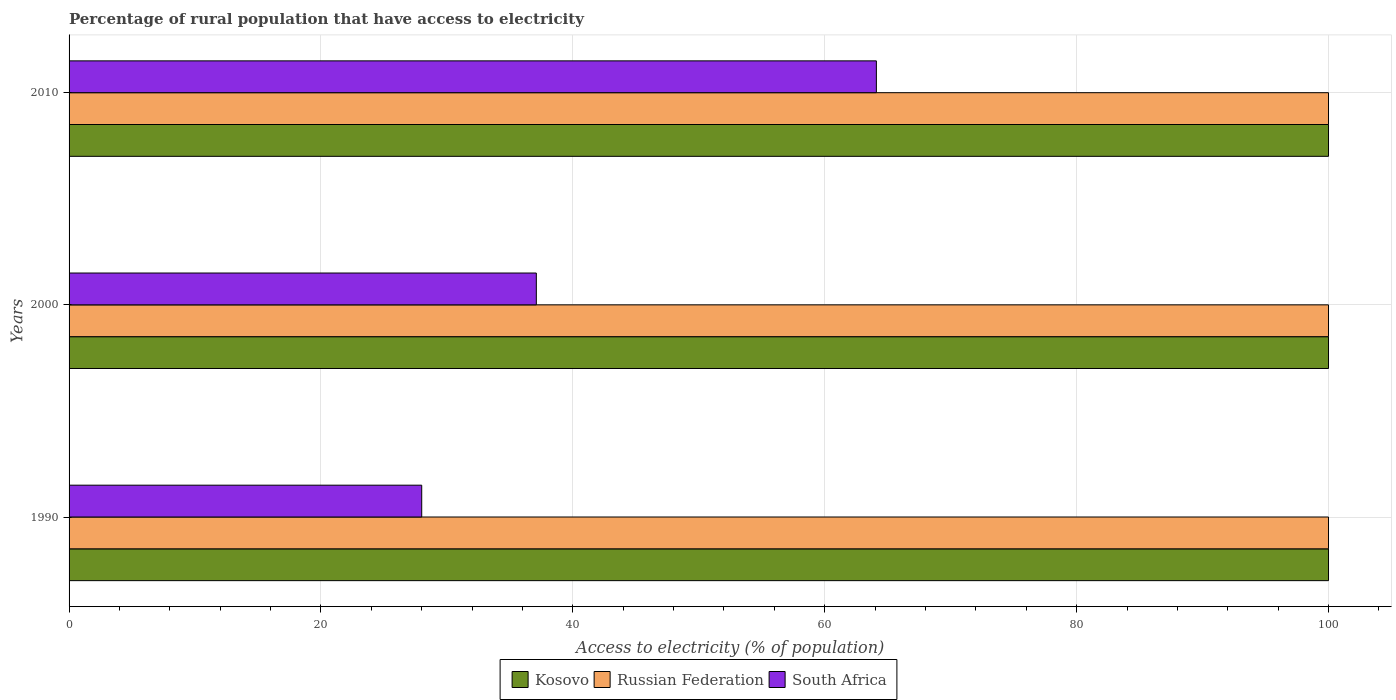How many different coloured bars are there?
Keep it short and to the point. 3. How many groups of bars are there?
Keep it short and to the point. 3. Are the number of bars per tick equal to the number of legend labels?
Offer a terse response. Yes. Are the number of bars on each tick of the Y-axis equal?
Give a very brief answer. Yes. How many bars are there on the 1st tick from the bottom?
Offer a terse response. 3. What is the label of the 3rd group of bars from the top?
Provide a succinct answer. 1990. In how many cases, is the number of bars for a given year not equal to the number of legend labels?
Your answer should be compact. 0. What is the percentage of rural population that have access to electricity in Russian Federation in 2000?
Offer a terse response. 100. Across all years, what is the maximum percentage of rural population that have access to electricity in Kosovo?
Your answer should be very brief. 100. Across all years, what is the minimum percentage of rural population that have access to electricity in Russian Federation?
Your response must be concise. 100. In which year was the percentage of rural population that have access to electricity in Russian Federation maximum?
Your response must be concise. 1990. What is the total percentage of rural population that have access to electricity in South Africa in the graph?
Ensure brevity in your answer.  129.2. What is the difference between the percentage of rural population that have access to electricity in Russian Federation in 1990 and that in 2010?
Offer a very short reply. 0. In the year 2000, what is the difference between the percentage of rural population that have access to electricity in South Africa and percentage of rural population that have access to electricity in Kosovo?
Offer a terse response. -62.9. In how many years, is the percentage of rural population that have access to electricity in South Africa greater than 100 %?
Provide a short and direct response. 0. Is the percentage of rural population that have access to electricity in South Africa in 1990 less than that in 2000?
Your answer should be very brief. Yes. Is the difference between the percentage of rural population that have access to electricity in South Africa in 1990 and 2010 greater than the difference between the percentage of rural population that have access to electricity in Kosovo in 1990 and 2010?
Give a very brief answer. No. What is the difference between the highest and the lowest percentage of rural population that have access to electricity in South Africa?
Keep it short and to the point. 36.1. In how many years, is the percentage of rural population that have access to electricity in Russian Federation greater than the average percentage of rural population that have access to electricity in Russian Federation taken over all years?
Give a very brief answer. 0. Is the sum of the percentage of rural population that have access to electricity in Kosovo in 1990 and 2010 greater than the maximum percentage of rural population that have access to electricity in Russian Federation across all years?
Offer a terse response. Yes. What does the 1st bar from the top in 2000 represents?
Provide a short and direct response. South Africa. What does the 2nd bar from the bottom in 2010 represents?
Offer a very short reply. Russian Federation. Are all the bars in the graph horizontal?
Keep it short and to the point. Yes. What is the difference between two consecutive major ticks on the X-axis?
Make the answer very short. 20. What is the title of the graph?
Offer a very short reply. Percentage of rural population that have access to electricity. What is the label or title of the X-axis?
Give a very brief answer. Access to electricity (% of population). What is the label or title of the Y-axis?
Your response must be concise. Years. What is the Access to electricity (% of population) of Kosovo in 1990?
Offer a very short reply. 100. What is the Access to electricity (% of population) of Kosovo in 2000?
Give a very brief answer. 100. What is the Access to electricity (% of population) of Russian Federation in 2000?
Your response must be concise. 100. What is the Access to electricity (% of population) in South Africa in 2000?
Your answer should be compact. 37.1. What is the Access to electricity (% of population) of South Africa in 2010?
Provide a succinct answer. 64.1. Across all years, what is the maximum Access to electricity (% of population) of South Africa?
Keep it short and to the point. 64.1. Across all years, what is the minimum Access to electricity (% of population) in Russian Federation?
Your answer should be very brief. 100. Across all years, what is the minimum Access to electricity (% of population) in South Africa?
Provide a short and direct response. 28. What is the total Access to electricity (% of population) in Kosovo in the graph?
Your answer should be very brief. 300. What is the total Access to electricity (% of population) in Russian Federation in the graph?
Provide a succinct answer. 300. What is the total Access to electricity (% of population) in South Africa in the graph?
Make the answer very short. 129.2. What is the difference between the Access to electricity (% of population) in South Africa in 1990 and that in 2000?
Your answer should be very brief. -9.1. What is the difference between the Access to electricity (% of population) of Russian Federation in 1990 and that in 2010?
Provide a short and direct response. 0. What is the difference between the Access to electricity (% of population) in South Africa in 1990 and that in 2010?
Make the answer very short. -36.1. What is the difference between the Access to electricity (% of population) in Kosovo in 2000 and that in 2010?
Make the answer very short. 0. What is the difference between the Access to electricity (% of population) in Russian Federation in 2000 and that in 2010?
Keep it short and to the point. 0. What is the difference between the Access to electricity (% of population) of South Africa in 2000 and that in 2010?
Make the answer very short. -27. What is the difference between the Access to electricity (% of population) in Kosovo in 1990 and the Access to electricity (% of population) in South Africa in 2000?
Offer a very short reply. 62.9. What is the difference between the Access to electricity (% of population) of Russian Federation in 1990 and the Access to electricity (% of population) of South Africa in 2000?
Offer a terse response. 62.9. What is the difference between the Access to electricity (% of population) in Kosovo in 1990 and the Access to electricity (% of population) in Russian Federation in 2010?
Offer a very short reply. 0. What is the difference between the Access to electricity (% of population) in Kosovo in 1990 and the Access to electricity (% of population) in South Africa in 2010?
Give a very brief answer. 35.9. What is the difference between the Access to electricity (% of population) of Russian Federation in 1990 and the Access to electricity (% of population) of South Africa in 2010?
Ensure brevity in your answer.  35.9. What is the difference between the Access to electricity (% of population) of Kosovo in 2000 and the Access to electricity (% of population) of Russian Federation in 2010?
Offer a very short reply. 0. What is the difference between the Access to electricity (% of population) of Kosovo in 2000 and the Access to electricity (% of population) of South Africa in 2010?
Your answer should be very brief. 35.9. What is the difference between the Access to electricity (% of population) of Russian Federation in 2000 and the Access to electricity (% of population) of South Africa in 2010?
Make the answer very short. 35.9. What is the average Access to electricity (% of population) of Russian Federation per year?
Offer a terse response. 100. What is the average Access to electricity (% of population) of South Africa per year?
Provide a succinct answer. 43.07. In the year 1990, what is the difference between the Access to electricity (% of population) of Kosovo and Access to electricity (% of population) of South Africa?
Your response must be concise. 72. In the year 1990, what is the difference between the Access to electricity (% of population) of Russian Federation and Access to electricity (% of population) of South Africa?
Provide a short and direct response. 72. In the year 2000, what is the difference between the Access to electricity (% of population) in Kosovo and Access to electricity (% of population) in South Africa?
Ensure brevity in your answer.  62.9. In the year 2000, what is the difference between the Access to electricity (% of population) of Russian Federation and Access to electricity (% of population) of South Africa?
Ensure brevity in your answer.  62.9. In the year 2010, what is the difference between the Access to electricity (% of population) in Kosovo and Access to electricity (% of population) in South Africa?
Offer a very short reply. 35.9. In the year 2010, what is the difference between the Access to electricity (% of population) of Russian Federation and Access to electricity (% of population) of South Africa?
Give a very brief answer. 35.9. What is the ratio of the Access to electricity (% of population) of Kosovo in 1990 to that in 2000?
Ensure brevity in your answer.  1. What is the ratio of the Access to electricity (% of population) of South Africa in 1990 to that in 2000?
Offer a very short reply. 0.75. What is the ratio of the Access to electricity (% of population) in South Africa in 1990 to that in 2010?
Provide a short and direct response. 0.44. What is the ratio of the Access to electricity (% of population) of South Africa in 2000 to that in 2010?
Your answer should be very brief. 0.58. What is the difference between the highest and the second highest Access to electricity (% of population) in Kosovo?
Your answer should be very brief. 0. What is the difference between the highest and the second highest Access to electricity (% of population) of South Africa?
Give a very brief answer. 27. What is the difference between the highest and the lowest Access to electricity (% of population) of Kosovo?
Ensure brevity in your answer.  0. What is the difference between the highest and the lowest Access to electricity (% of population) of South Africa?
Make the answer very short. 36.1. 